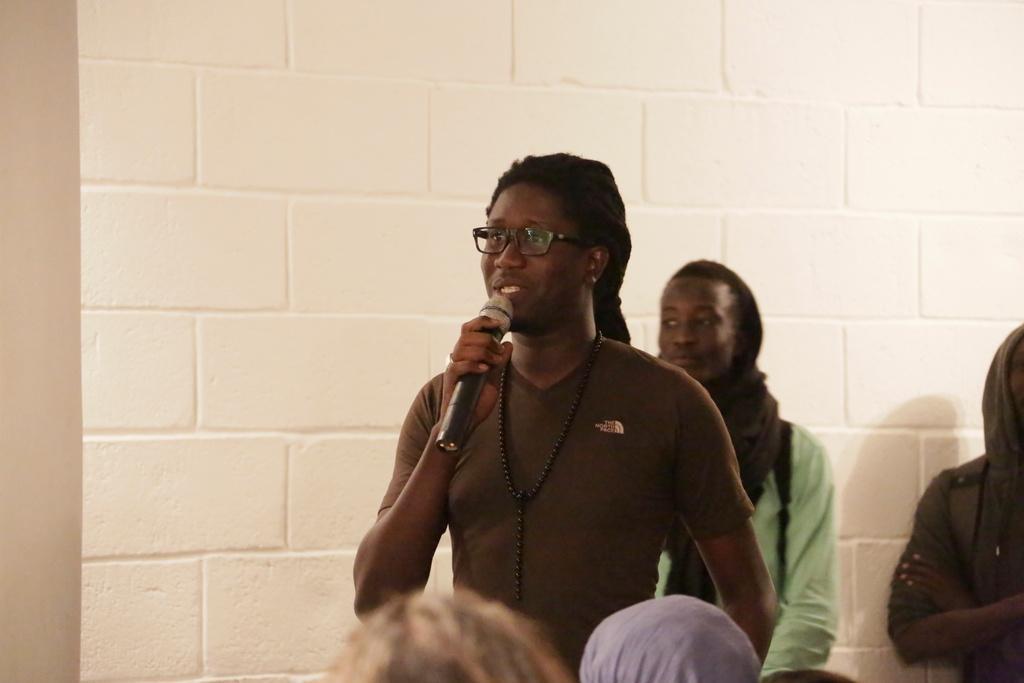How would you summarize this image in a sentence or two? In this picture we can see a person holding a mic, wearing a spectacles, here we can see people and we can see a wall in the background. 